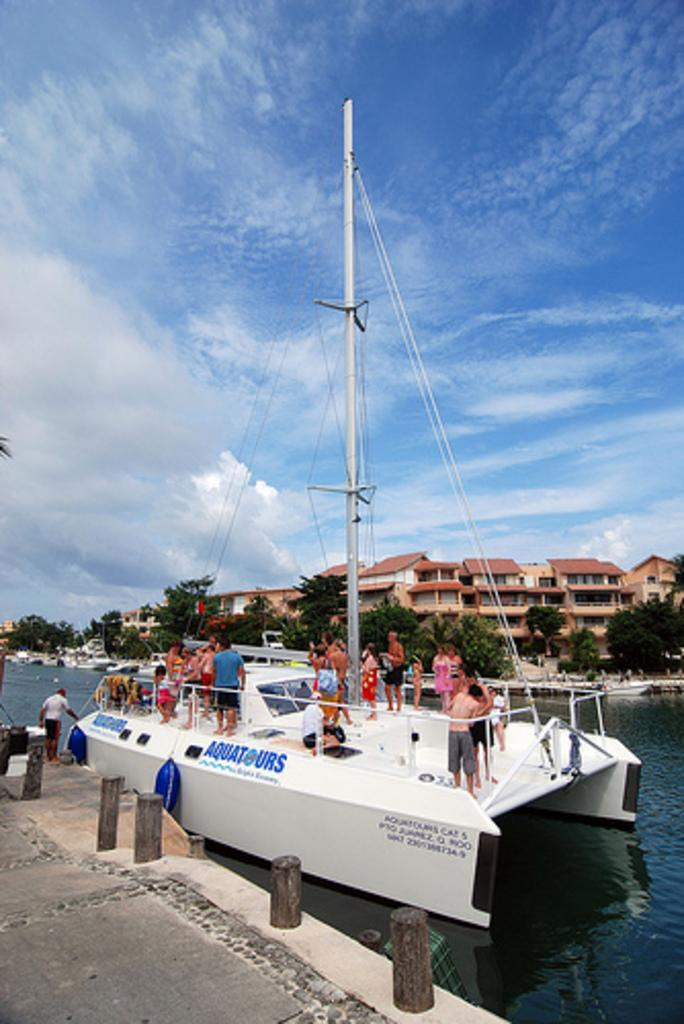What is the main subject of the image? The main subject of the image is a boat. Where is the boat located? The boat is on a river. Are there any people on the boat? Yes, there are people standing on the boat. What can be seen in the background of the image? There are trees, houses, and the sky visible in the background of the image. What type of gun is being used by the stranger in the image? There is no stranger or gun present in the image; it features a boat on a river with people standing on it. 